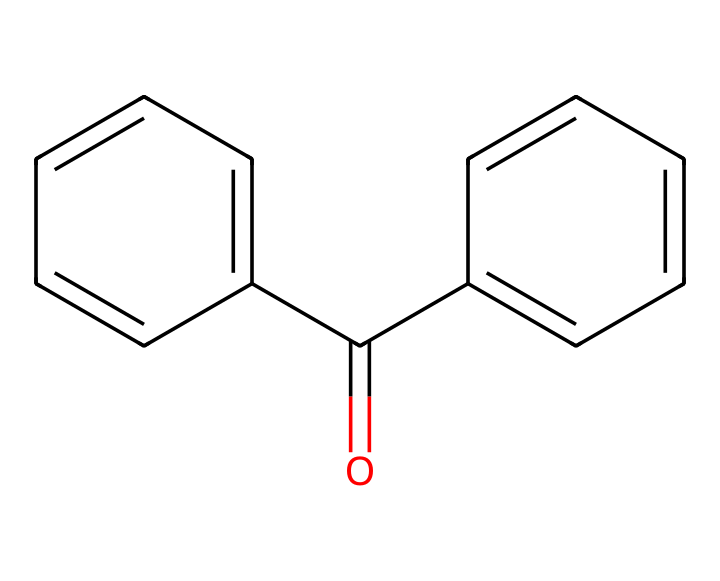What is the number of carbon atoms in benzophenone? The given structure includes two phenyl groups and one carbonyl group. Each phenyl group has six carbon atoms, and the carbonyl carbon adds one more, totaling 13 carbon atoms.
Answer: 13 How many double bonds are present in this compound? The benzophenone structure shows five double bonds: four in the two phenyl rings (two each) and one in the carbonyl group.
Answer: 5 What functional group is present in benzophenone? The carbonyl group (C=O) indicates that benzophenone is a ketone, which is the characteristic functional group of ketones.
Answer: ketone What type of ultraviolet light does benzophenone absorb? Benzophenone typically absorbs UV-A (320-400 nm) radiation, which is the type of UV light used in many sunscreen formulations.
Answer: UV-A How many aromatic rings are present in the structure of benzophenone? The structure of benzophenone contains two aromatic rings (the two phenyl groups) that are connected by the carbonyl group.
Answer: 2 Is benzophenone polar or nonpolar? Due to the presence of the carbonyl group and the structure's overall arrangement, benzophenone is considered a slightly polar compound, but its aromatic groups contribute to some nonpolar characteristics.
Answer: slightly polar 